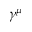<formula> <loc_0><loc_0><loc_500><loc_500>\gamma ^ { \mu }</formula> 